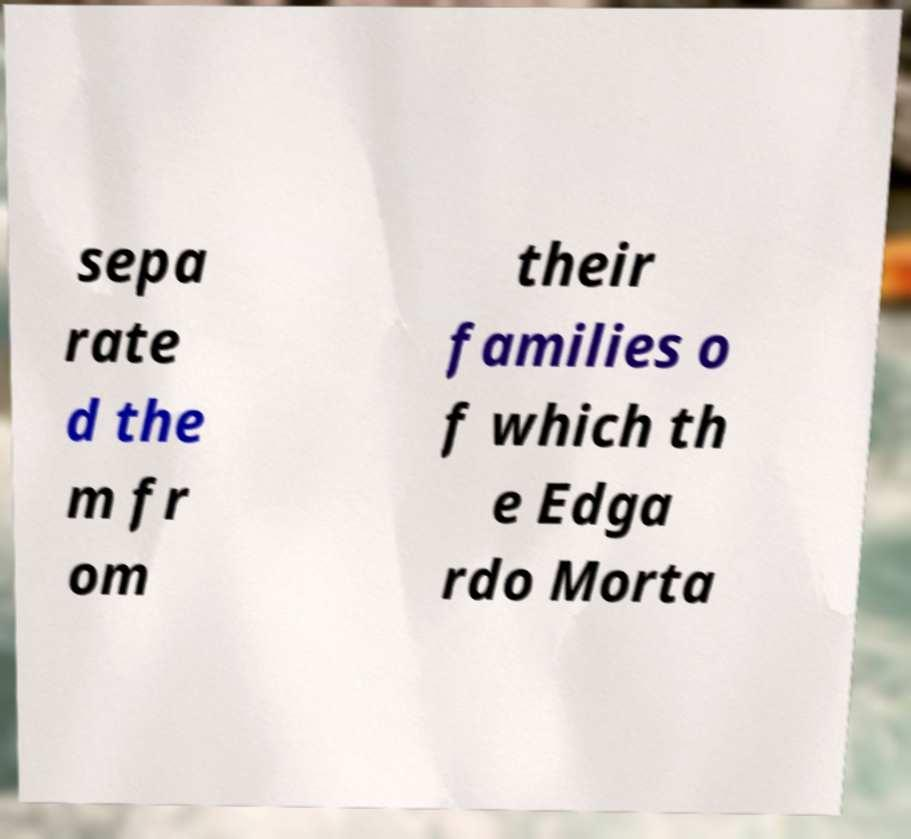Can you accurately transcribe the text from the provided image for me? sepa rate d the m fr om their families o f which th e Edga rdo Morta 